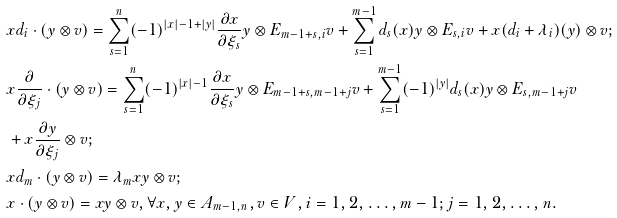Convert formula to latex. <formula><loc_0><loc_0><loc_500><loc_500>& x d _ { i } \cdot ( y \otimes v ) = \sum _ { s = 1 } ^ { n } ( - 1 ) ^ { | x | - 1 + | y | } \frac { \partial x } { \partial \xi _ { s } } y \otimes E _ { m - 1 + s , i } v + \sum _ { s = 1 } ^ { m - 1 } d _ { s } ( x ) y \otimes E _ { s , i } v + x ( d _ { i } + \lambda _ { i } ) ( y ) \otimes v ; \\ & x \frac { \partial } { \partial \xi _ { j } } \cdot ( y \otimes v ) = \sum _ { s = 1 } ^ { n } ( - 1 ) ^ { | x | - 1 } \frac { \partial x } { \partial { \xi _ { s } } } y \otimes E _ { m - 1 + s , m - 1 + j } v + \sum _ { s = 1 } ^ { m - 1 } ( - 1 ) ^ { | y | } d _ { s } ( x ) y \otimes E _ { s , m - 1 + j } v \\ & + x \frac { \partial y } { \partial \xi _ { j } } \otimes v ; \\ & x d _ { m } \cdot ( y \otimes v ) = \lambda _ { m } x y \otimes v ; \\ & x \cdot ( y \otimes v ) = x y \otimes v , \forall x , y \in A _ { m - 1 , n } , v \in V , i = 1 , 2 , \dots , m - 1 ; j = 1 , 2 , \dots , n .</formula> 